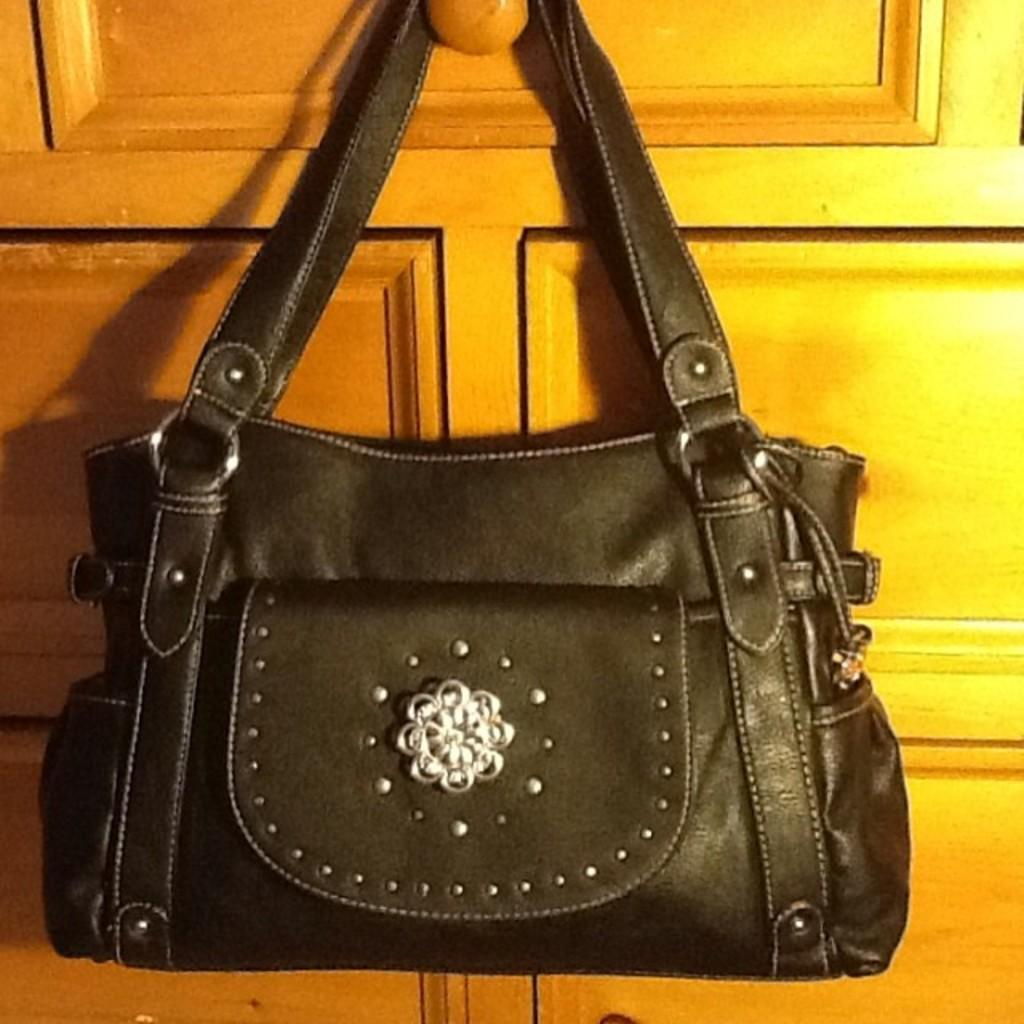What type of handbag is visible in the image? There is a black color leather handbag in the image. Where is the handbag located in the image? The handbag is hanged on a door. What type of rod is used to hang the handbag on the door? There is no rod visible in the image; the handbag is simply hanged on the door. Can you tell me how fast the handbag is running in the image? The handbag is not running in the image; it is stationary when hanged on the door. 